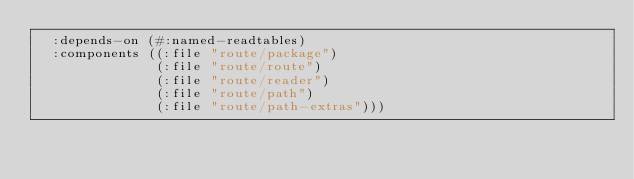Convert code to text. <code><loc_0><loc_0><loc_500><loc_500><_Lisp_>  :depends-on (#:named-readtables)
  :components ((:file "route/package")
               (:file "route/route")
               (:file "route/reader")
               (:file "route/path")
               (:file "route/path-extras")))
</code> 